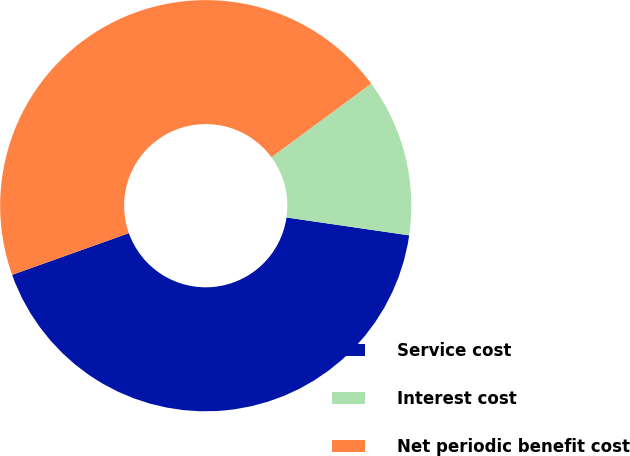Convert chart. <chart><loc_0><loc_0><loc_500><loc_500><pie_chart><fcel>Service cost<fcel>Interest cost<fcel>Net periodic benefit cost<nl><fcel>42.24%<fcel>12.42%<fcel>45.34%<nl></chart> 